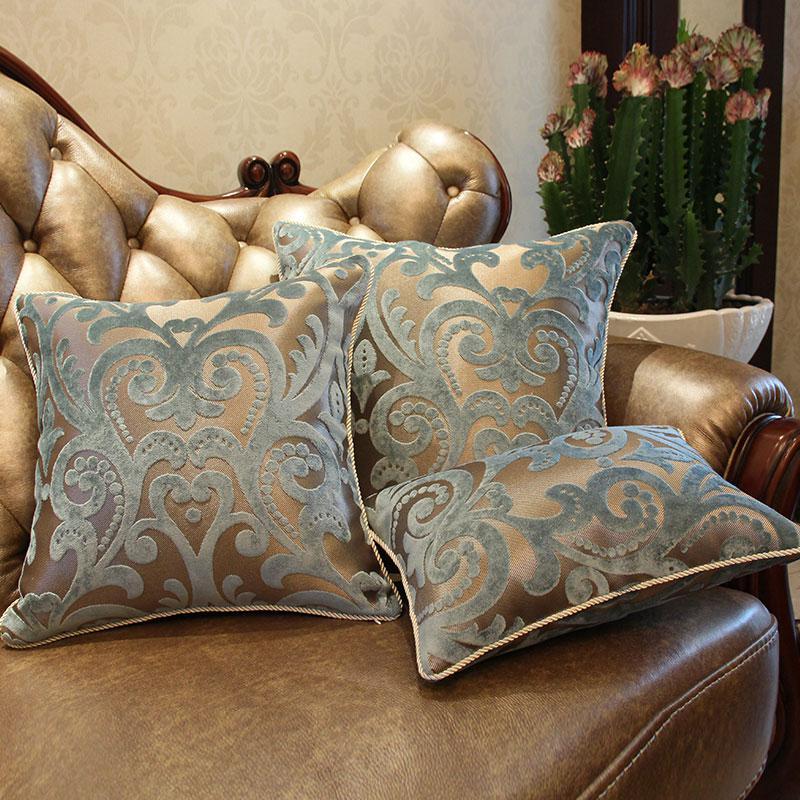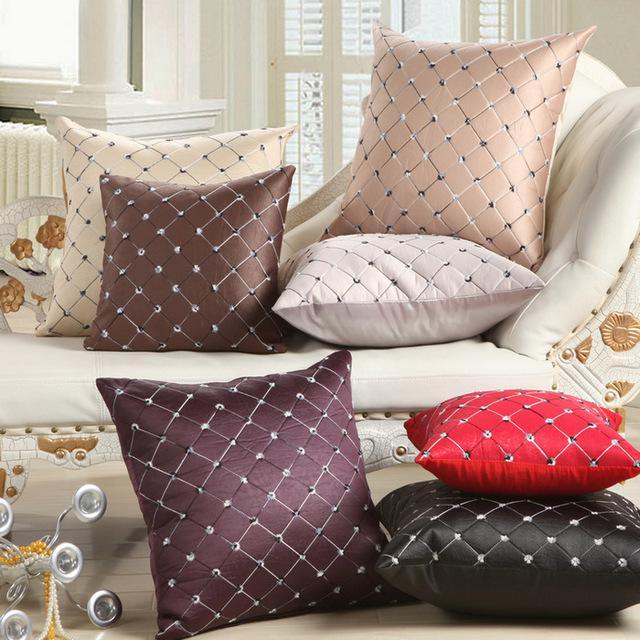The first image is the image on the left, the second image is the image on the right. Examine the images to the left and right. Is the description "Two different colored pillows are stacked horizontally on a floor beside no more than two other different colored pillows." accurate? Answer yes or no. Yes. The first image is the image on the left, the second image is the image on the right. For the images displayed, is the sentence "One image features at least one pillow with button closures, and the other image contains at least 7 square pillows of different colors." factually correct? Answer yes or no. No. 